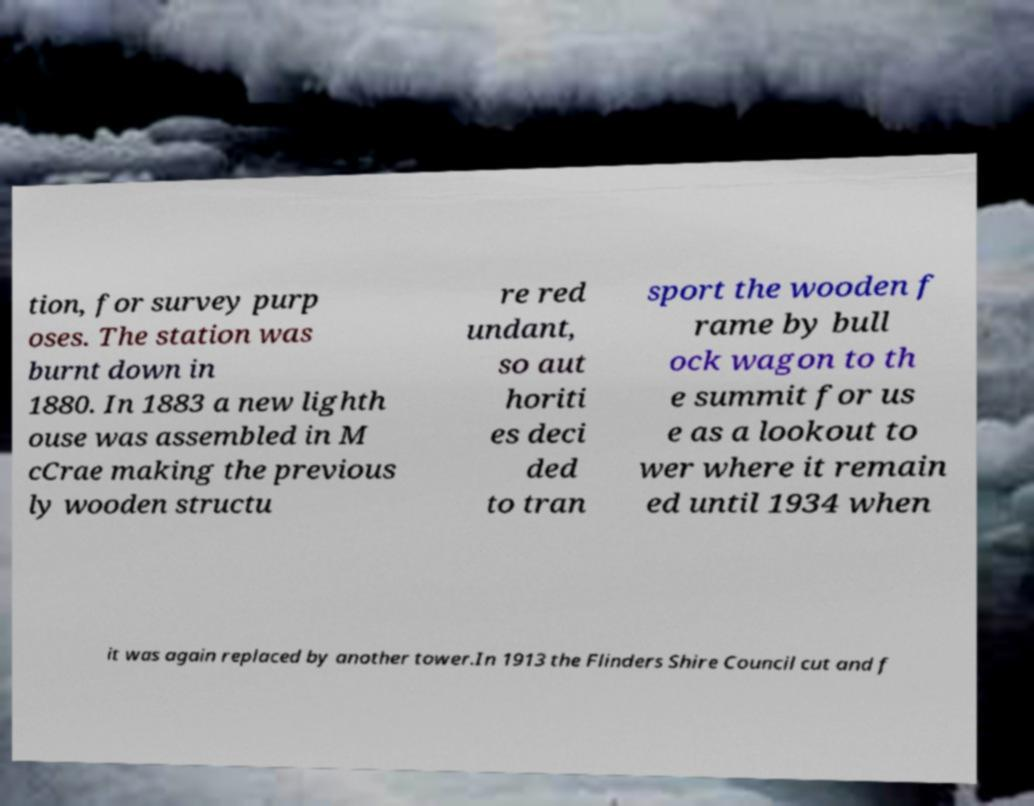Can you read and provide the text displayed in the image?This photo seems to have some interesting text. Can you extract and type it out for me? tion, for survey purp oses. The station was burnt down in 1880. In 1883 a new lighth ouse was assembled in M cCrae making the previous ly wooden structu re red undant, so aut horiti es deci ded to tran sport the wooden f rame by bull ock wagon to th e summit for us e as a lookout to wer where it remain ed until 1934 when it was again replaced by another tower.In 1913 the Flinders Shire Council cut and f 